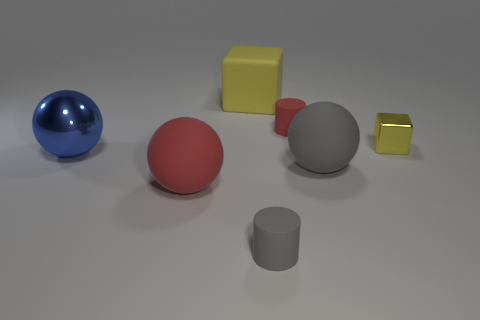Subtract all big gray rubber spheres. How many spheres are left? 2 Add 3 tiny yellow objects. How many objects exist? 10 Subtract all gray cylinders. How many cylinders are left? 1 Subtract all cubes. How many objects are left? 5 Add 5 big gray things. How many big gray things are left? 6 Add 5 large cubes. How many large cubes exist? 6 Subtract 0 green cylinders. How many objects are left? 7 Subtract all yellow balls. Subtract all purple cylinders. How many balls are left? 3 Subtract all red matte cubes. Subtract all red rubber spheres. How many objects are left? 6 